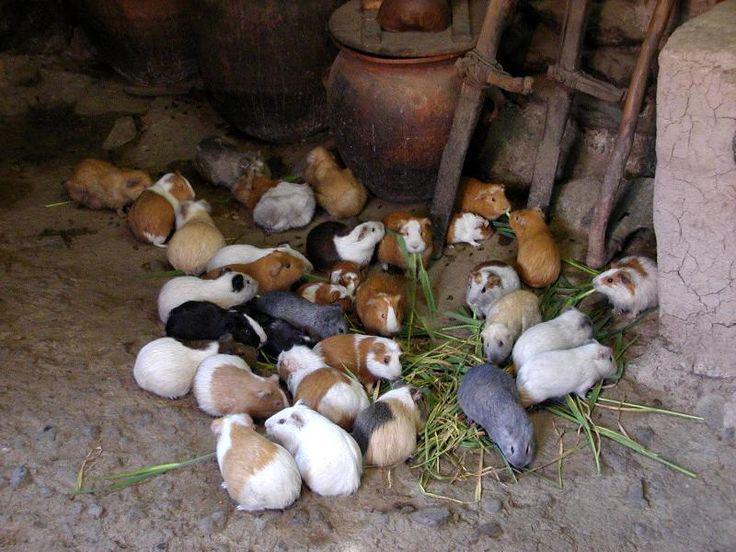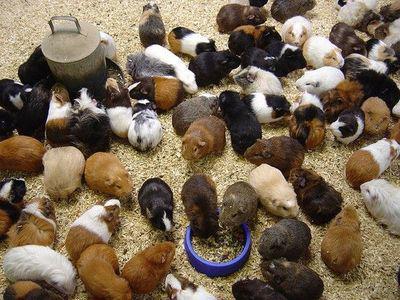The first image is the image on the left, the second image is the image on the right. Evaluate the accuracy of this statement regarding the images: "One image includes no more than five hamsters.". Is it true? Answer yes or no. No. The first image is the image on the left, the second image is the image on the right. Assess this claim about the two images: "The guinea pigs are eating in both images and are eating fresh green vegetation in one of the images.". Correct or not? Answer yes or no. Yes. 